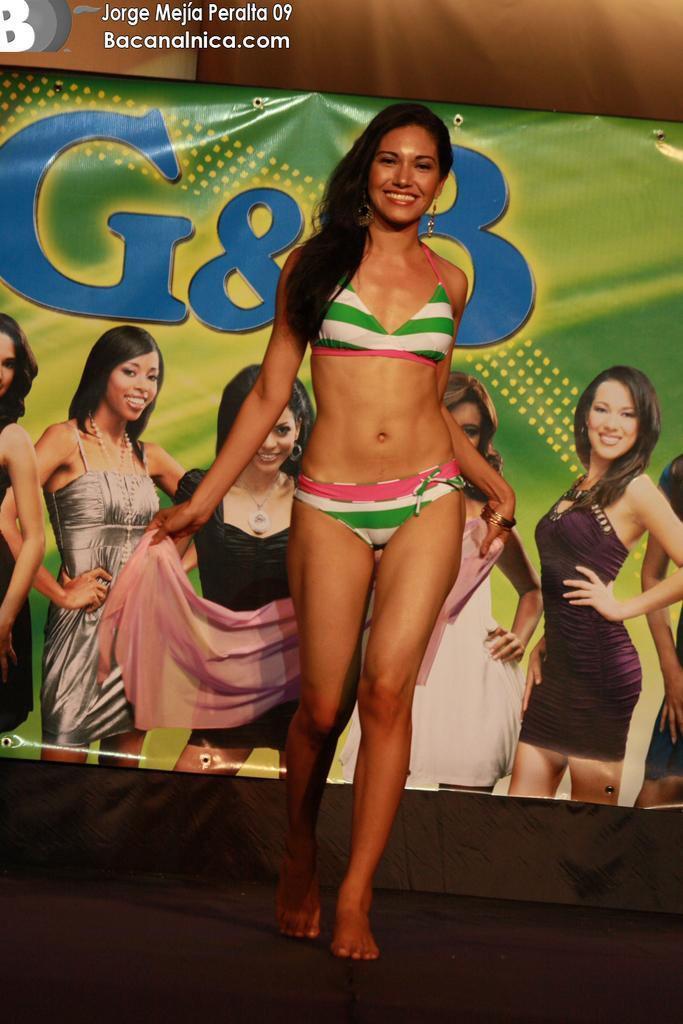Could you give a brief overview of what you see in this image? In the center of the image there is a lady walking. In the background of the image there is a banner. At the bottom of the image there is black color surface. 